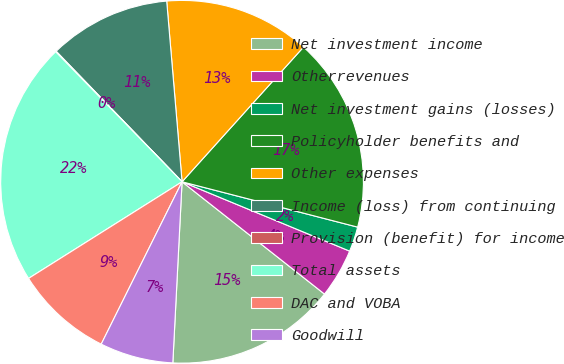Convert chart to OTSL. <chart><loc_0><loc_0><loc_500><loc_500><pie_chart><fcel>Net investment income<fcel>Otherrevenues<fcel>Net investment gains (losses)<fcel>Policyholder benefits and<fcel>Other expenses<fcel>Income (loss) from continuing<fcel>Provision (benefit) for income<fcel>Total assets<fcel>DAC and VOBA<fcel>Goodwill<nl><fcel>15.18%<fcel>4.38%<fcel>2.22%<fcel>17.34%<fcel>13.02%<fcel>10.86%<fcel>0.06%<fcel>21.66%<fcel>8.7%<fcel>6.54%<nl></chart> 